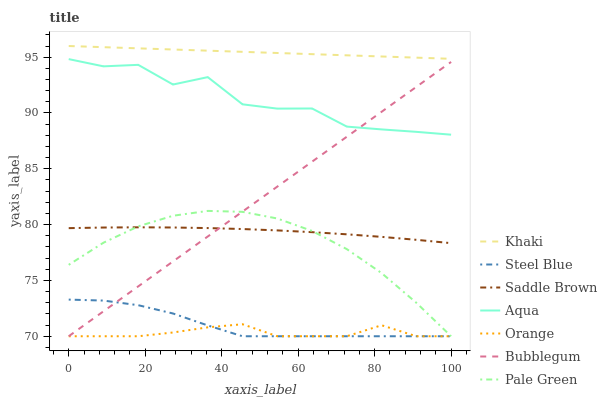Does Orange have the minimum area under the curve?
Answer yes or no. Yes. Does Khaki have the maximum area under the curve?
Answer yes or no. Yes. Does Aqua have the minimum area under the curve?
Answer yes or no. No. Does Aqua have the maximum area under the curve?
Answer yes or no. No. Is Khaki the smoothest?
Answer yes or no. Yes. Is Aqua the roughest?
Answer yes or no. Yes. Is Steel Blue the smoothest?
Answer yes or no. No. Is Steel Blue the roughest?
Answer yes or no. No. Does Steel Blue have the lowest value?
Answer yes or no. Yes. Does Aqua have the lowest value?
Answer yes or no. No. Does Khaki have the highest value?
Answer yes or no. Yes. Does Aqua have the highest value?
Answer yes or no. No. Is Orange less than Saddle Brown?
Answer yes or no. Yes. Is Khaki greater than Saddle Brown?
Answer yes or no. Yes. Does Bubblegum intersect Aqua?
Answer yes or no. Yes. Is Bubblegum less than Aqua?
Answer yes or no. No. Is Bubblegum greater than Aqua?
Answer yes or no. No. Does Orange intersect Saddle Brown?
Answer yes or no. No. 